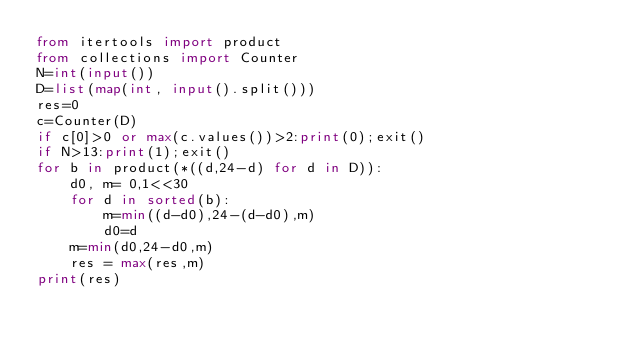Convert code to text. <code><loc_0><loc_0><loc_500><loc_500><_Python_>from itertools import product
from collections import Counter
N=int(input())
D=list(map(int, input().split()))
res=0
c=Counter(D)
if c[0]>0 or max(c.values())>2:print(0);exit()
if N>13:print(1);exit()
for b in product(*((d,24-d) for d in D)):
    d0, m= 0,1<<30
    for d in sorted(b):
        m=min((d-d0),24-(d-d0),m)
        d0=d
    m=min(d0,24-d0,m)
    res = max(res,m)
print(res)</code> 